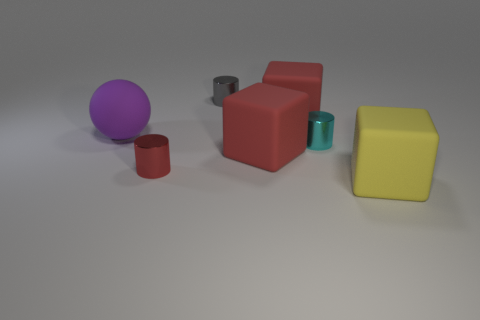Add 3 spheres. How many objects exist? 10 Subtract all spheres. How many objects are left? 6 Add 3 cyan metal things. How many cyan metal things are left? 4 Add 7 big red cubes. How many big red cubes exist? 9 Subtract 0 brown blocks. How many objects are left? 7 Subtract all gray metallic objects. Subtract all gray balls. How many objects are left? 6 